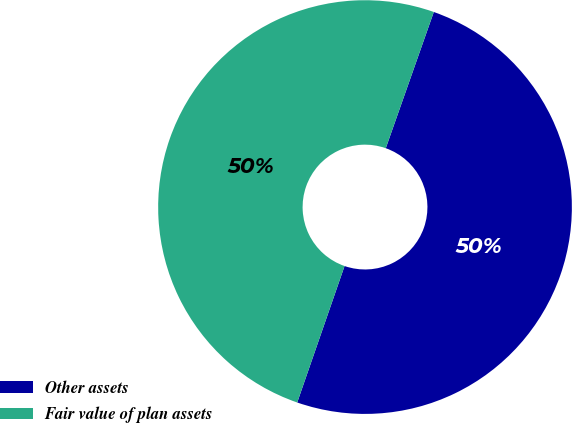<chart> <loc_0><loc_0><loc_500><loc_500><pie_chart><fcel>Other assets<fcel>Fair value of plan assets<nl><fcel>49.92%<fcel>50.08%<nl></chart> 